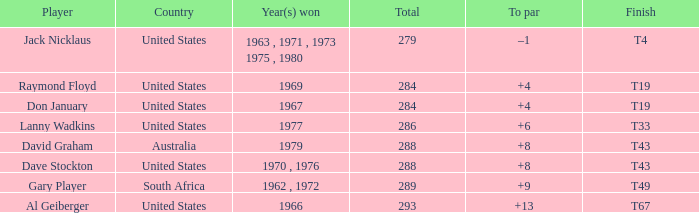Who triumphed in 1979 with +8 above par? David Graham. 